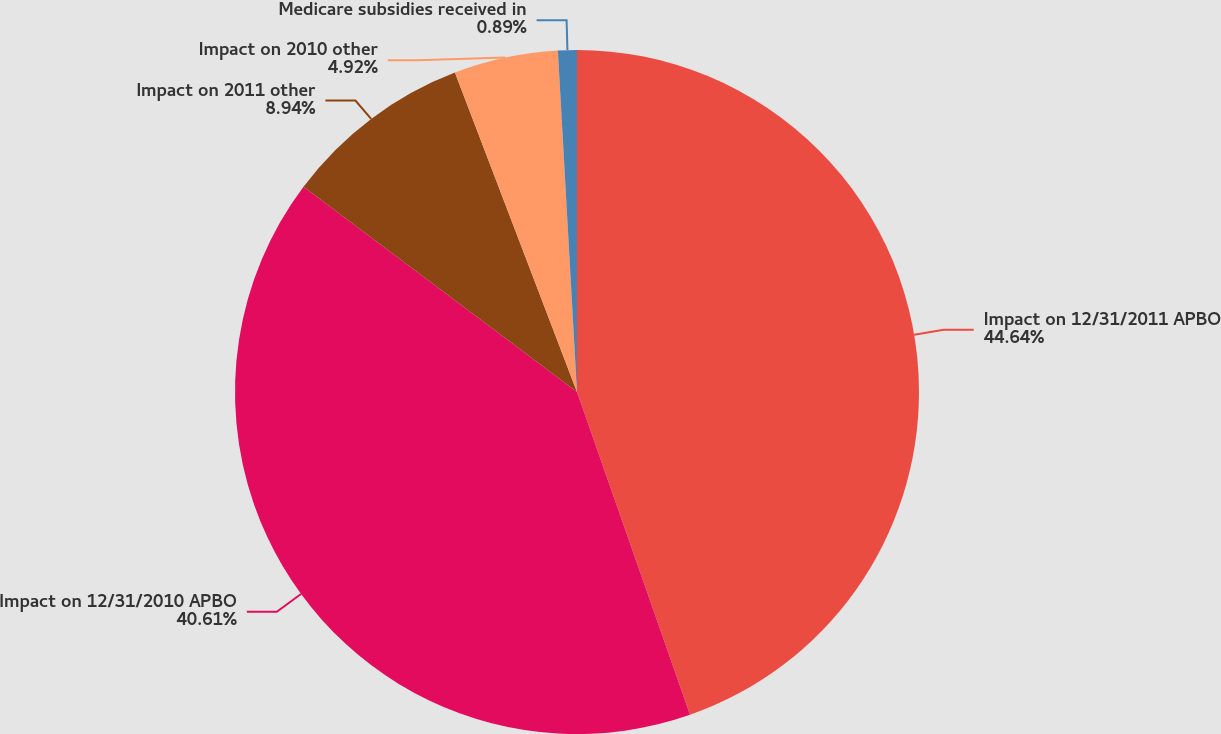Convert chart. <chart><loc_0><loc_0><loc_500><loc_500><pie_chart><fcel>Impact on 12/31/2011 APBO<fcel>Impact on 12/31/2010 APBO<fcel>Impact on 2011 other<fcel>Impact on 2010 other<fcel>Medicare subsidies received in<nl><fcel>44.64%<fcel>40.61%<fcel>8.94%<fcel>4.92%<fcel>0.89%<nl></chart> 